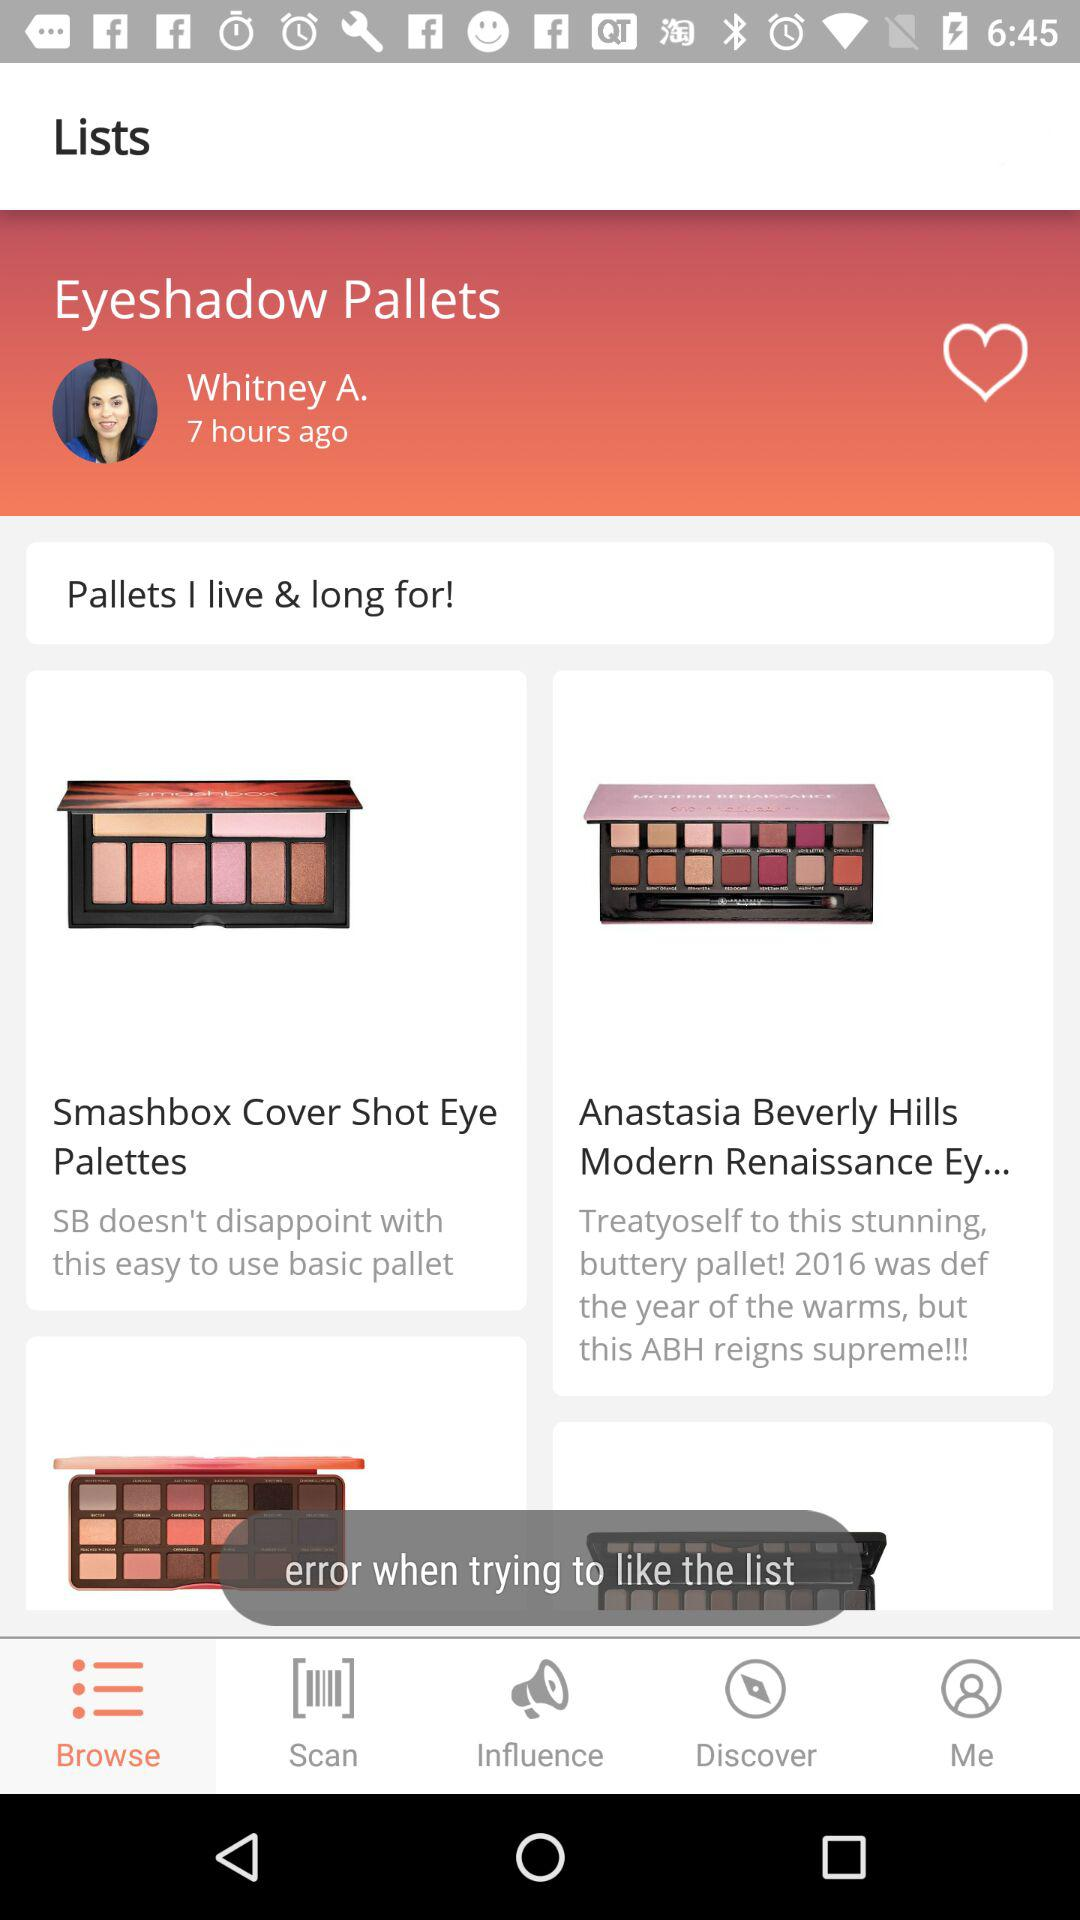When was the "Eyeshadow Pallets" list posted? The "Eyeshadow Pallets" list was posted 7 hours ago. 